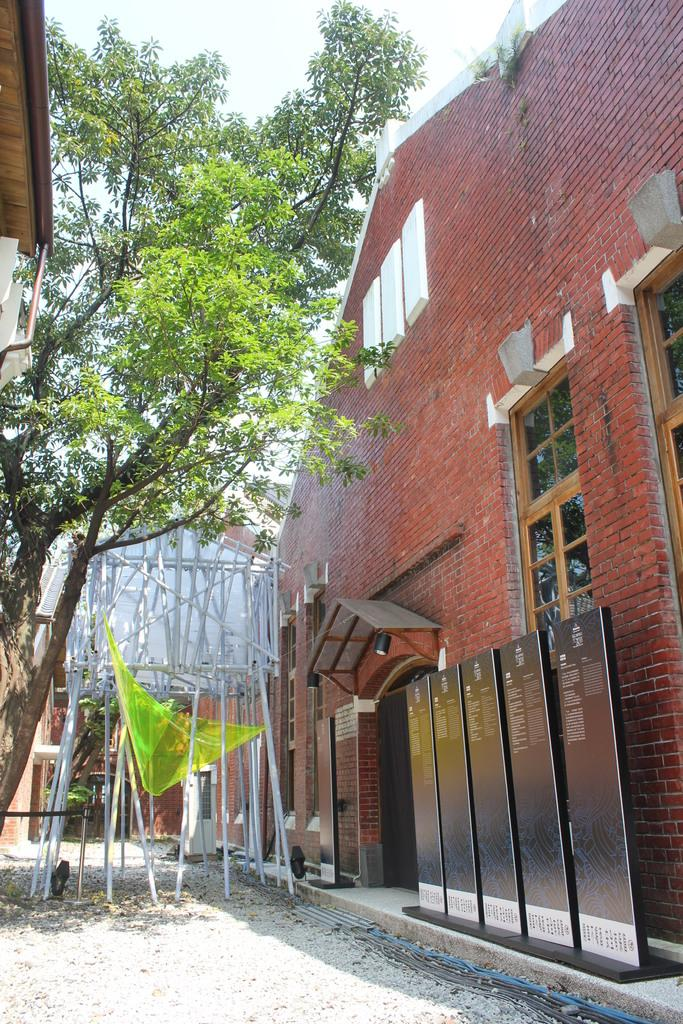What type of structure is visible in the image? There is a building with windows in the image. What can be seen on the boards in the image? There are boards with text in the image. What type of plant is present in the image? There is a tree in the image. What are the poles on the ground used for in the image? The poles on the ground are likely used for support or signage. What is the condition of the sky in the image? The sky is visible in the image and appears cloudy. What type of oatmeal is being served in the image? There is no oatmeal present in the image. How does the balance of the building affect its stability in the image? The image does not provide information about the balance or stability of the building. 